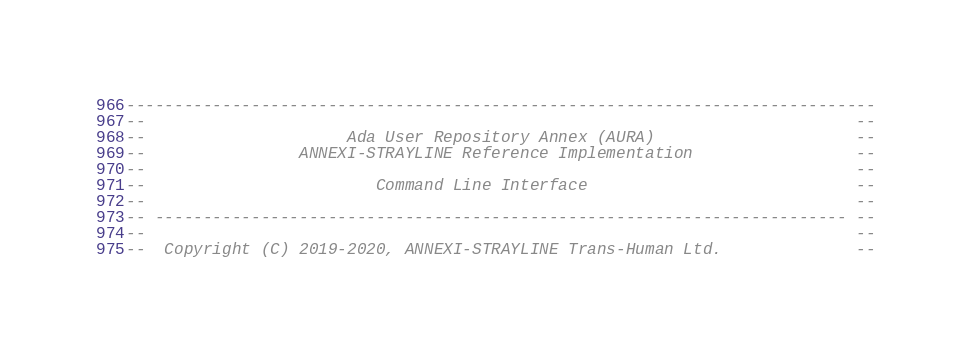Convert code to text. <code><loc_0><loc_0><loc_500><loc_500><_Ada_>------------------------------------------------------------------------------
--                                                                          --
--                     Ada User Repository Annex (AURA)                     --
--                ANNEXI-STRAYLINE Reference Implementation                 --
--                                                                          --
--                        Command Line Interface                            --
--                                                                          --
-- ------------------------------------------------------------------------ --
--                                                                          --
--  Copyright (C) 2019-2020, ANNEXI-STRAYLINE Trans-Human Ltd.              --</code> 